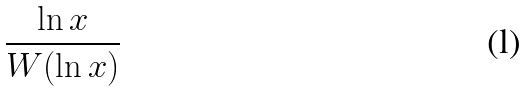<formula> <loc_0><loc_0><loc_500><loc_500>\frac { \ln x } { W ( \ln x ) }</formula> 